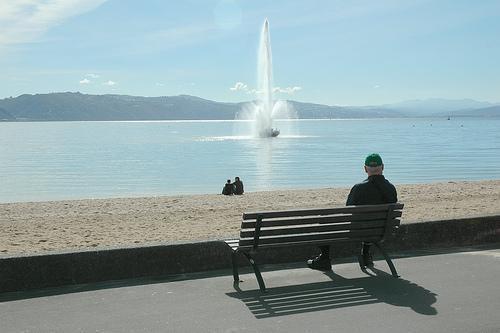How many people are pictured?
Give a very brief answer. 3. How many people are sitting on the sand?
Give a very brief answer. 2. 